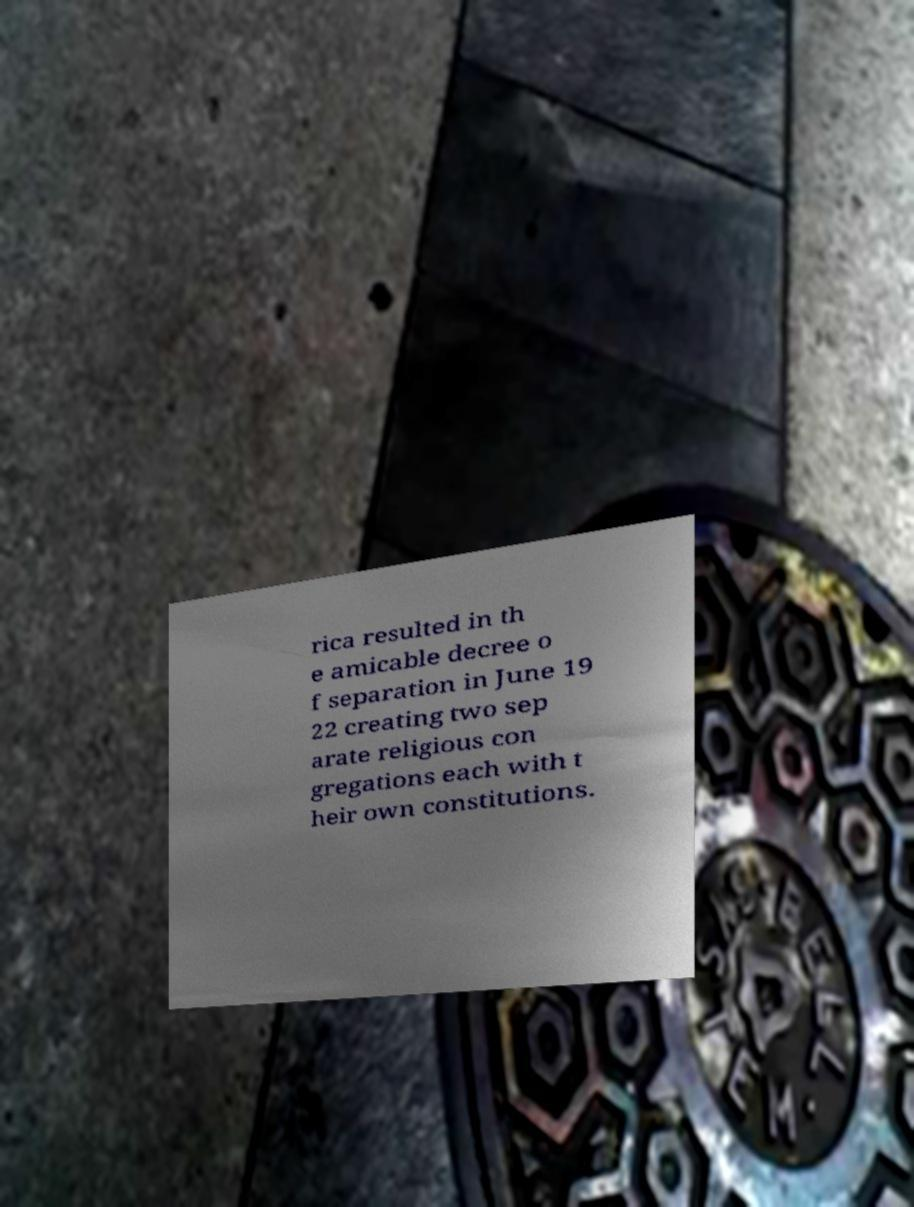Please read and relay the text visible in this image. What does it say? rica resulted in th e amicable decree o f separation in June 19 22 creating two sep arate religious con gregations each with t heir own constitutions. 